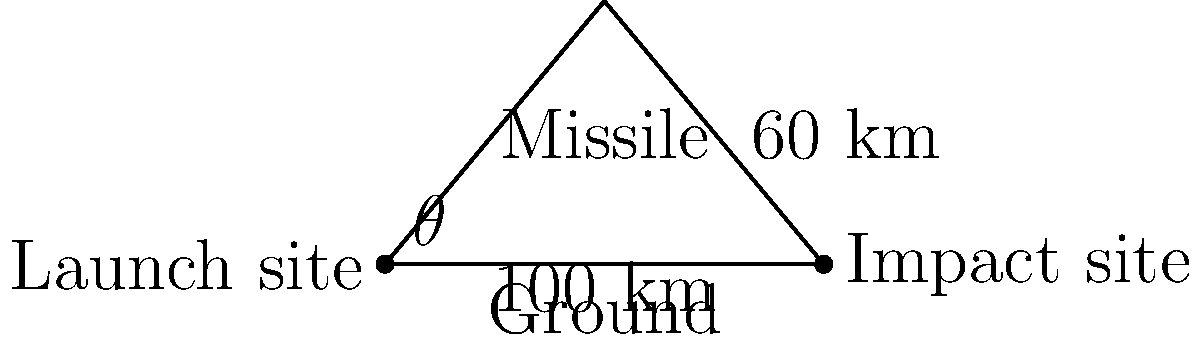A new missile system is being developed with a range of 100 km and a maximum altitude of 60 km. Calculate the launch angle $\theta$ required for this trajectory. If successful, this project is estimated to create 500 new jobs for every 5° increase in the launch angle. How many new jobs are expected to be created based on the calculated angle? 1. To find the launch angle $\theta$, we need to use trigonometry in the right-angled triangle formed by the missile's trajectory.

2. The tangent of the angle is the ratio of the opposite side to the adjacent side:

   $\tan(\theta) = \frac{\text{opposite}}{\text{adjacent}} = \frac{60}{50} = 1.2$

3. To find $\theta$, we take the inverse tangent (arctangent):

   $\theta = \arctan(1.2) \approx 50.2°$

4. Now, we need to calculate how many 5° increments this angle represents:

   $\text{Number of increments} = \frac{50.2°}{5°} \approx 10.04$

5. Since we can't have a fractional number of increments, we round down to 10.

6. Each increment represents 500 new jobs, so:

   $\text{Total new jobs} = 10 \times 500 = 5,000$

Therefore, based on the calculated launch angle of approximately 50.2°, an estimated 5,000 new jobs are expected to be created in the local economy.
Answer: 5,000 new jobs 